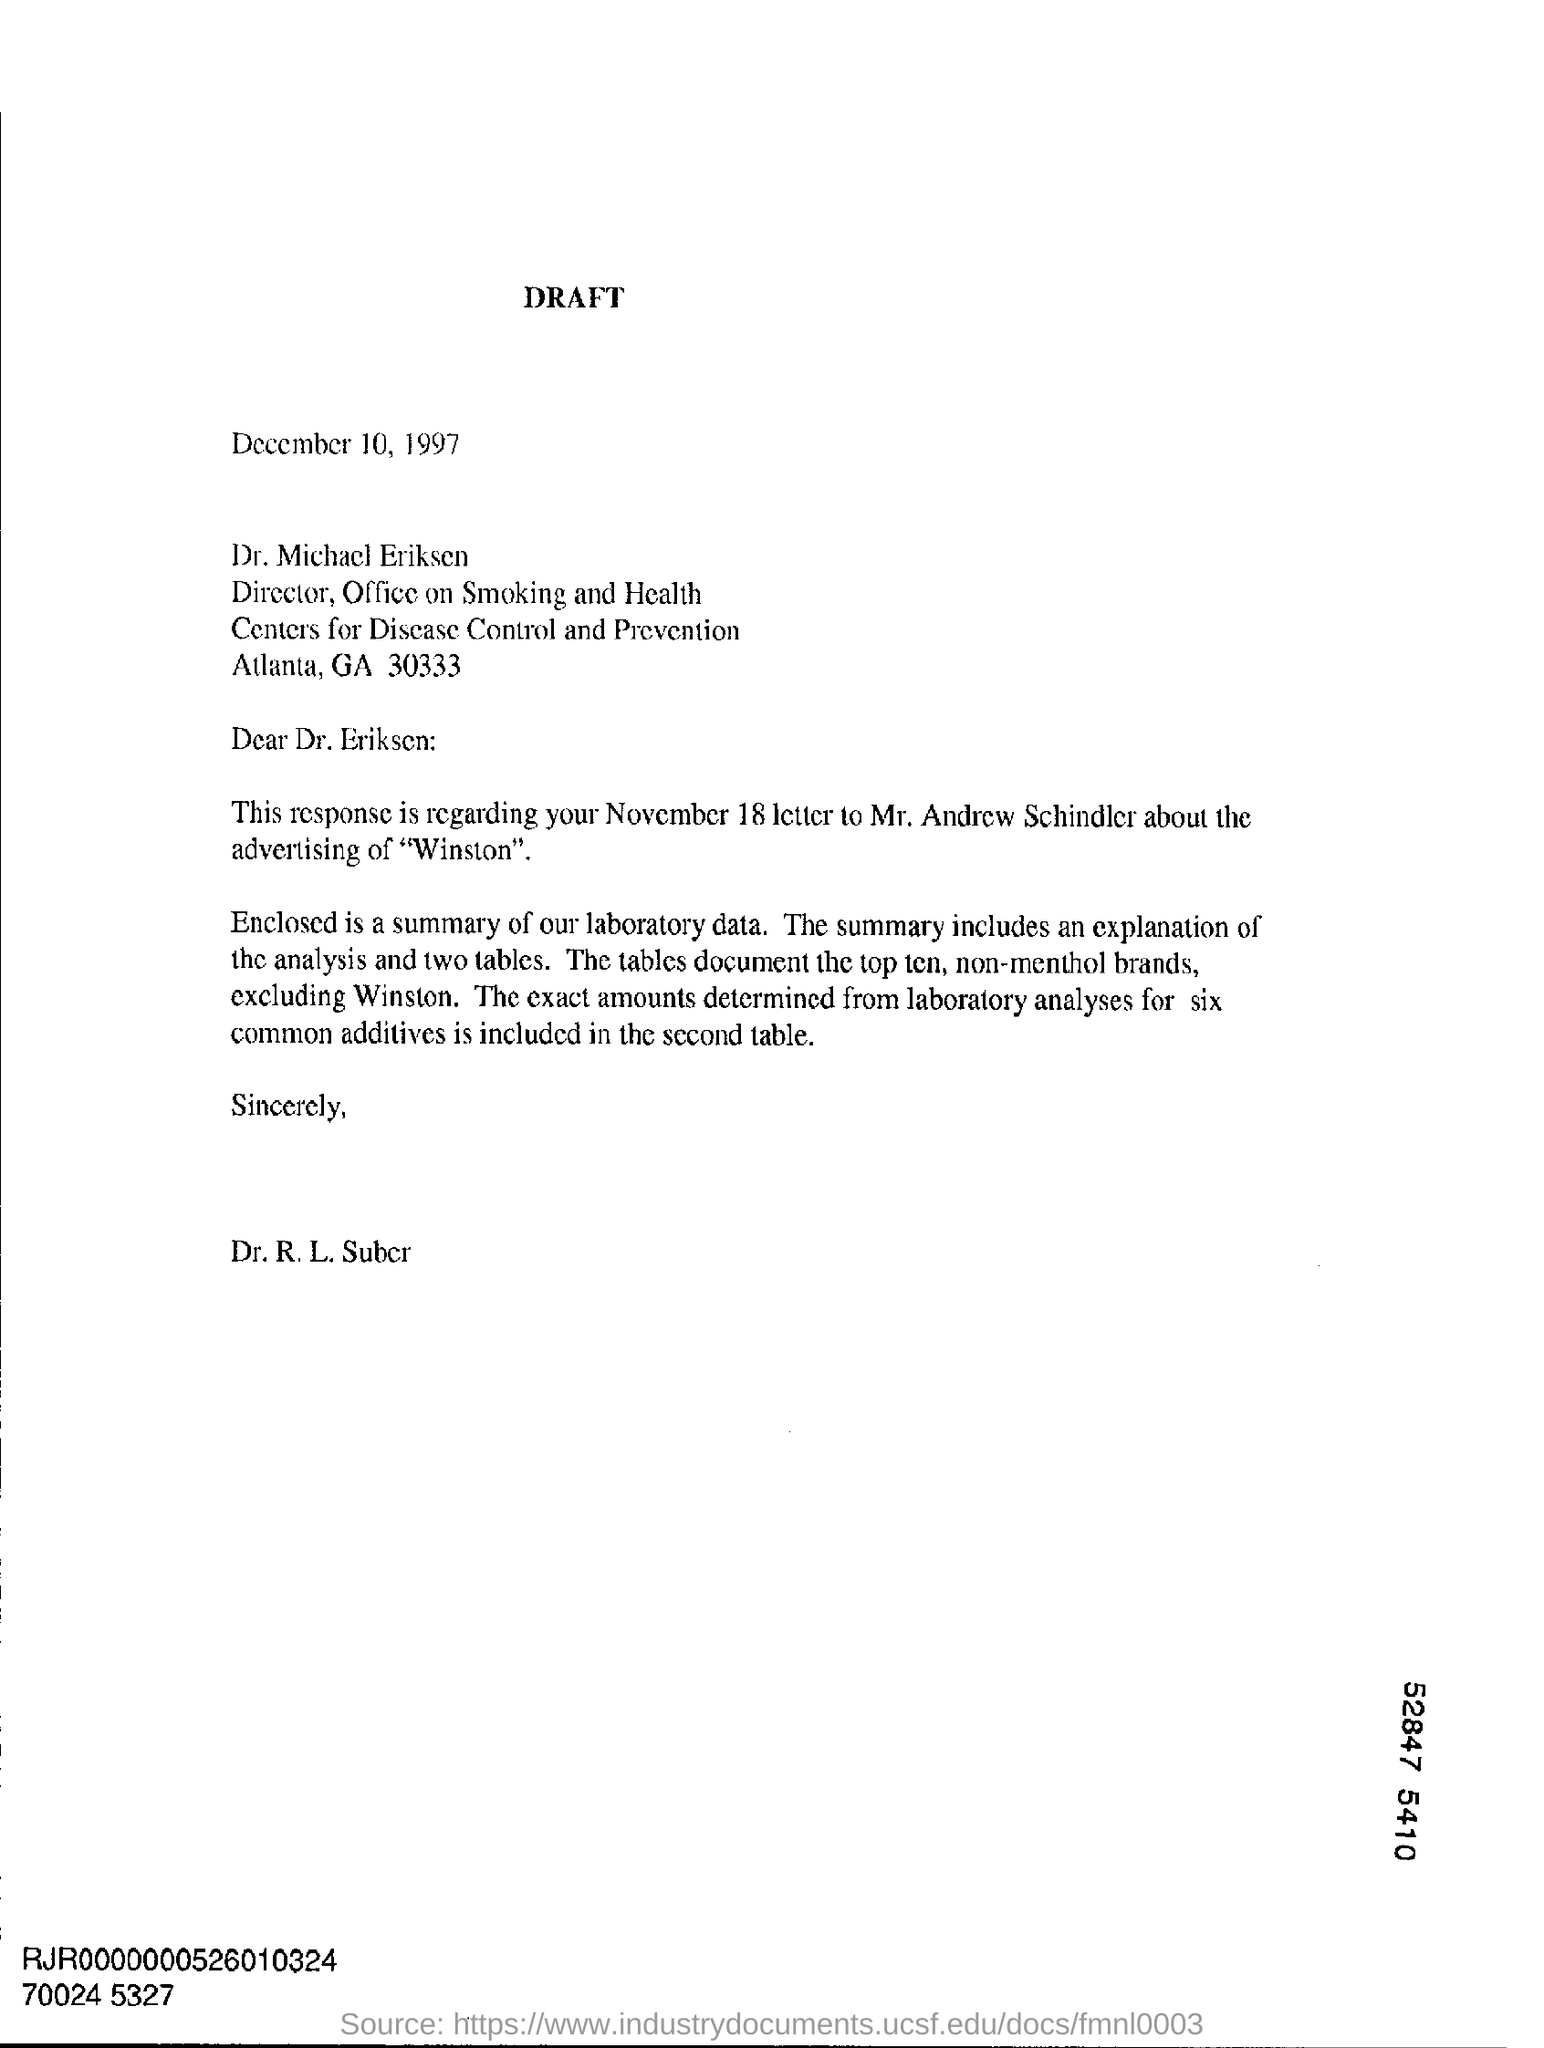Specify some key components in this picture. The letter is addressed to Dr. Michael Eriksen. The date on the document is December 10, 1997. 